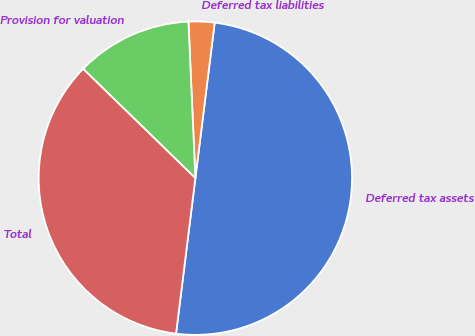Convert chart. <chart><loc_0><loc_0><loc_500><loc_500><pie_chart><fcel>Deferred tax assets<fcel>Deferred tax liabilities<fcel>Provision for valuation<fcel>Total<nl><fcel>50.0%<fcel>2.67%<fcel>12.01%<fcel>35.32%<nl></chart> 